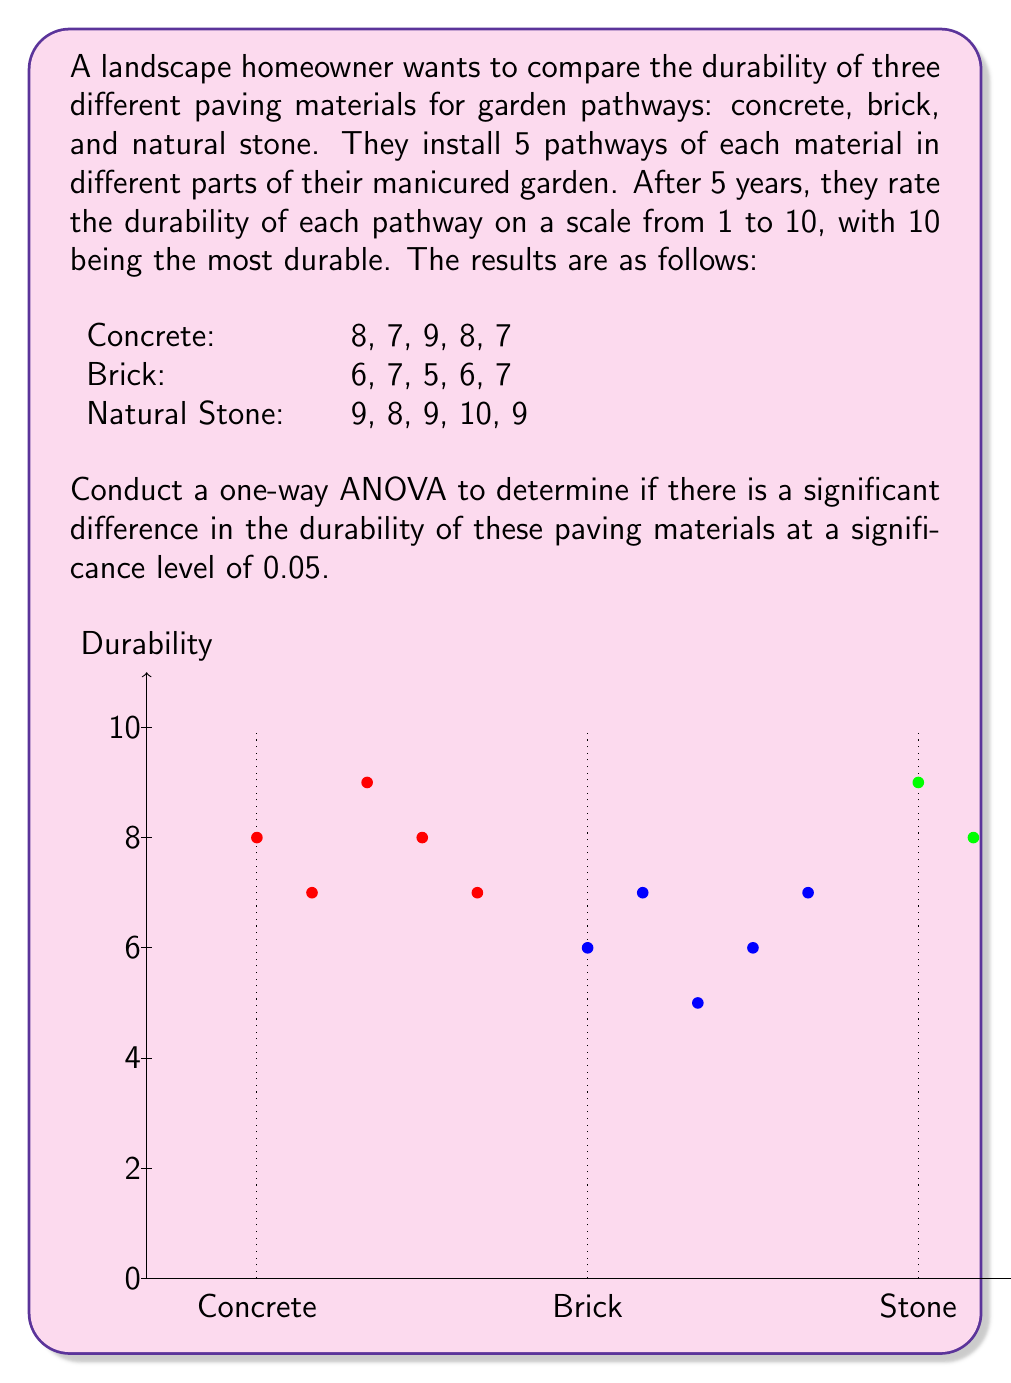Show me your answer to this math problem. To conduct a one-way ANOVA, we need to follow these steps:

1. Calculate the sum of squares between groups (SSB) and within groups (SSW).
2. Calculate the degrees of freedom for between groups (dfB) and within groups (dfW).
3. Calculate the mean squares between groups (MSB) and within groups (MSW).
4. Calculate the F-statistic.
5. Compare the F-statistic with the critical F-value.

Step 1: Calculate SSB and SSW

First, we need to calculate the grand mean:
$$\bar{X} = \frac{(8+7+9+8+7) + (6+7+5+6+7) + (9+8+9+10+9)}{15} = 7.67$$

Now, we calculate the sum of squares between groups (SSB):
$$SSB = 5[(7.8 - 7.67)^2 + (6.2 - 7.67)^2 + (9 - 7.67)^2] = 24.13$$

For the sum of squares within groups (SSW), we calculate:
$$SSW = [(8-7.8)^2 + (7-7.8)^2 + (9-7.8)^2 + (8-7.8)^2 + (7-7.8)^2] + \\
[(6-6.2)^2 + (7-6.2)^2 + (5-6.2)^2 + (6-6.2)^2 + (7-6.2)^2] + \\
[(9-9)^2 + (8-9)^2 + (9-9)^2 + (10-9)^2 + (9-9)^2] = 10.8$$

Step 2: Calculate degrees of freedom

$$df_B = k - 1 = 3 - 1 = 2$$
$$df_W = N - k = 15 - 3 = 12$$

Where k is the number of groups and N is the total number of observations.

Step 3: Calculate mean squares

$$MSB = \frac{SSB}{df_B} = \frac{24.13}{2} = 12.065$$
$$MSW = \frac{SSW}{df_W} = \frac{10.8}{12} = 0.9$$

Step 4: Calculate F-statistic

$$F = \frac{MSB}{MSW} = \frac{12.065}{0.9} = 13.41$$

Step 5: Compare F-statistic with critical F-value

The critical F-value for $\alpha = 0.05$, $df_B = 2$, and $df_W = 12$ is approximately 3.89.

Since our calculated F-statistic (13.41) is greater than the critical F-value (3.89), we reject the null hypothesis.
Answer: Reject null hypothesis; significant difference in durability (F = 13.41, p < 0.05) 